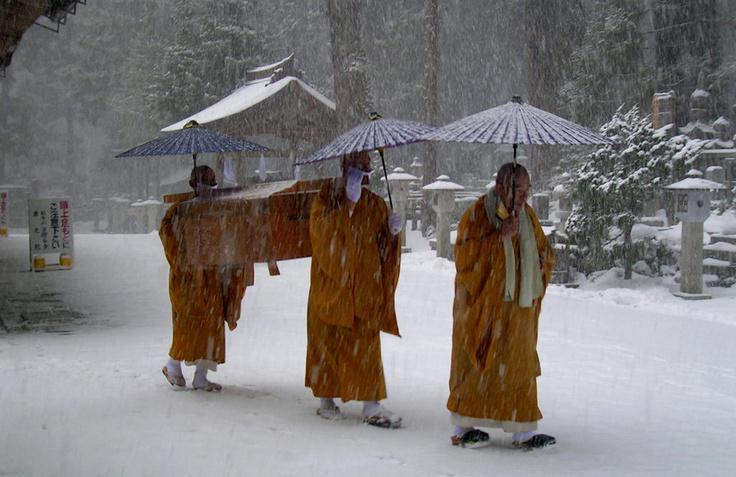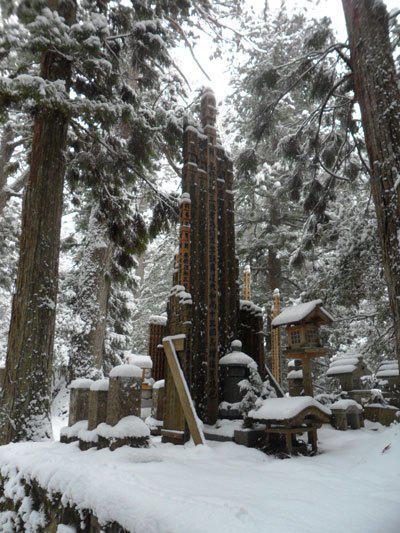The first image is the image on the left, the second image is the image on the right. Considering the images on both sides, is "The red posts of a Buddhist shrine can be seen in one image, while a single monk walks on a stone path in the other image." valid? Answer yes or no. No. The first image is the image on the left, the second image is the image on the right. For the images displayed, is the sentence "An image shows at least three people in golden-yellow robes walking in a snowy scene." factually correct? Answer yes or no. Yes. 